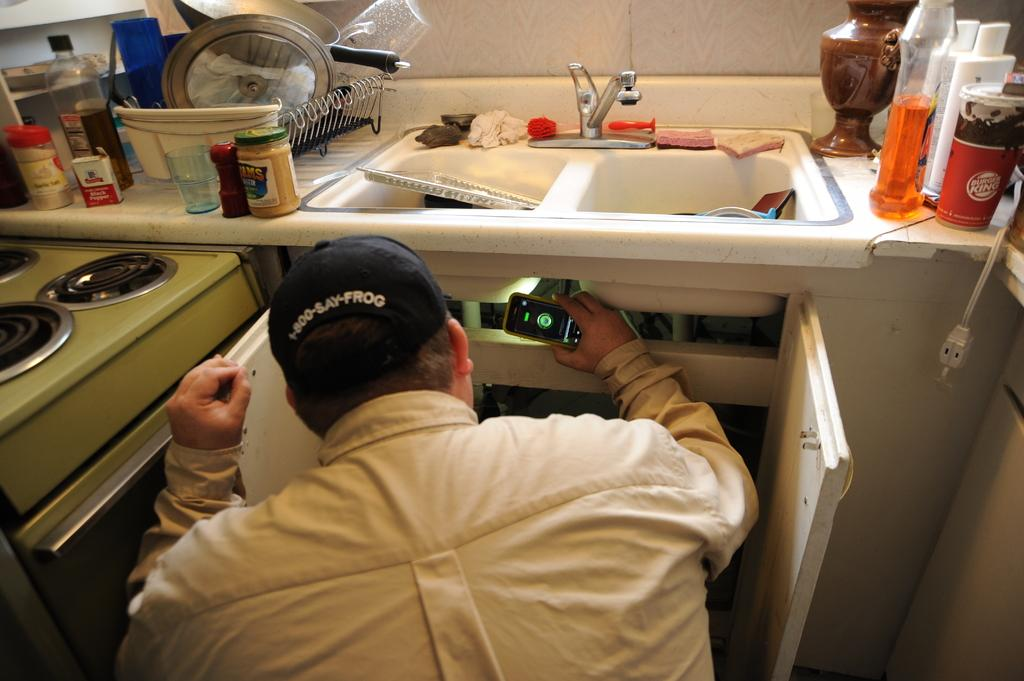Provide a one-sentence caption for the provided image. Man looking under the sink that has a Burger King soda on top. 